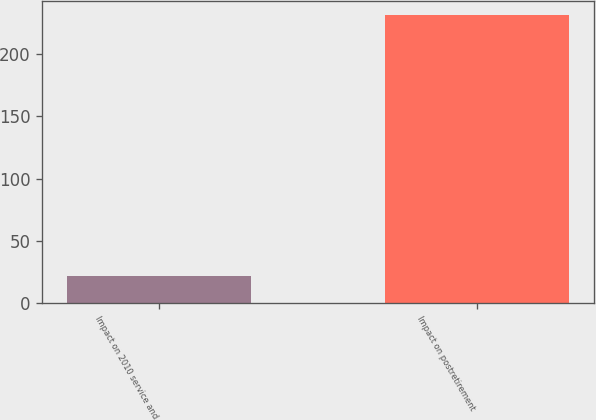Convert chart. <chart><loc_0><loc_0><loc_500><loc_500><bar_chart><fcel>Impact on 2010 service and<fcel>Impact on postretirement<nl><fcel>22<fcel>231<nl></chart> 